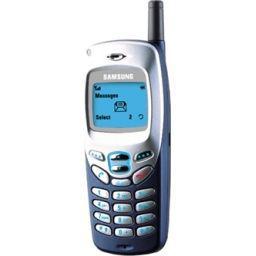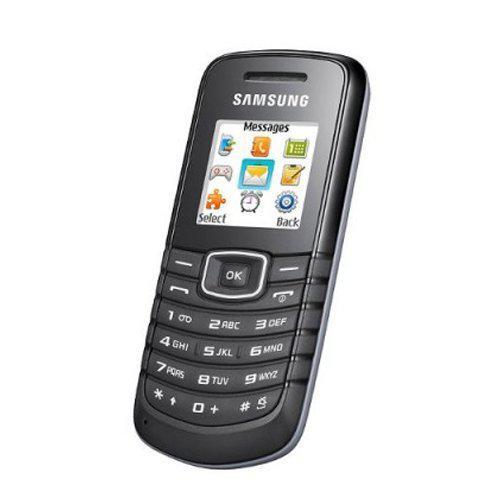The first image is the image on the left, the second image is the image on the right. Given the left and right images, does the statement "The right image shows an opened flip phone." hold true? Answer yes or no. No. The first image is the image on the left, the second image is the image on the right. Examine the images to the left and right. Is the description "There are more phones in the image on the right." accurate? Answer yes or no. No. 